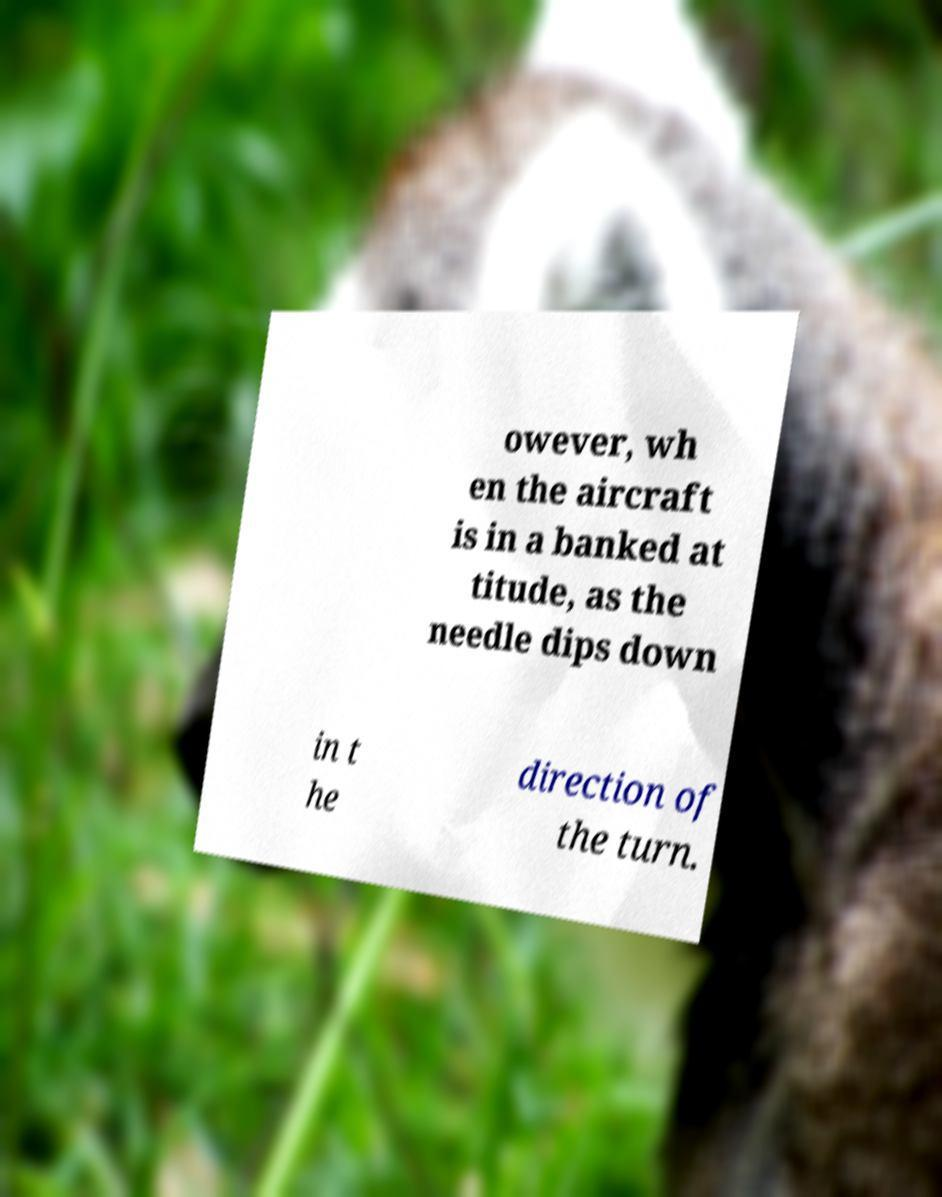There's text embedded in this image that I need extracted. Can you transcribe it verbatim? owever, wh en the aircraft is in a banked at titude, as the needle dips down in t he direction of the turn. 